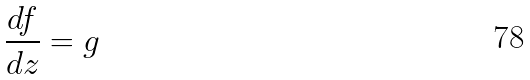<formula> <loc_0><loc_0><loc_500><loc_500>\frac { d f } { d z } = g</formula> 